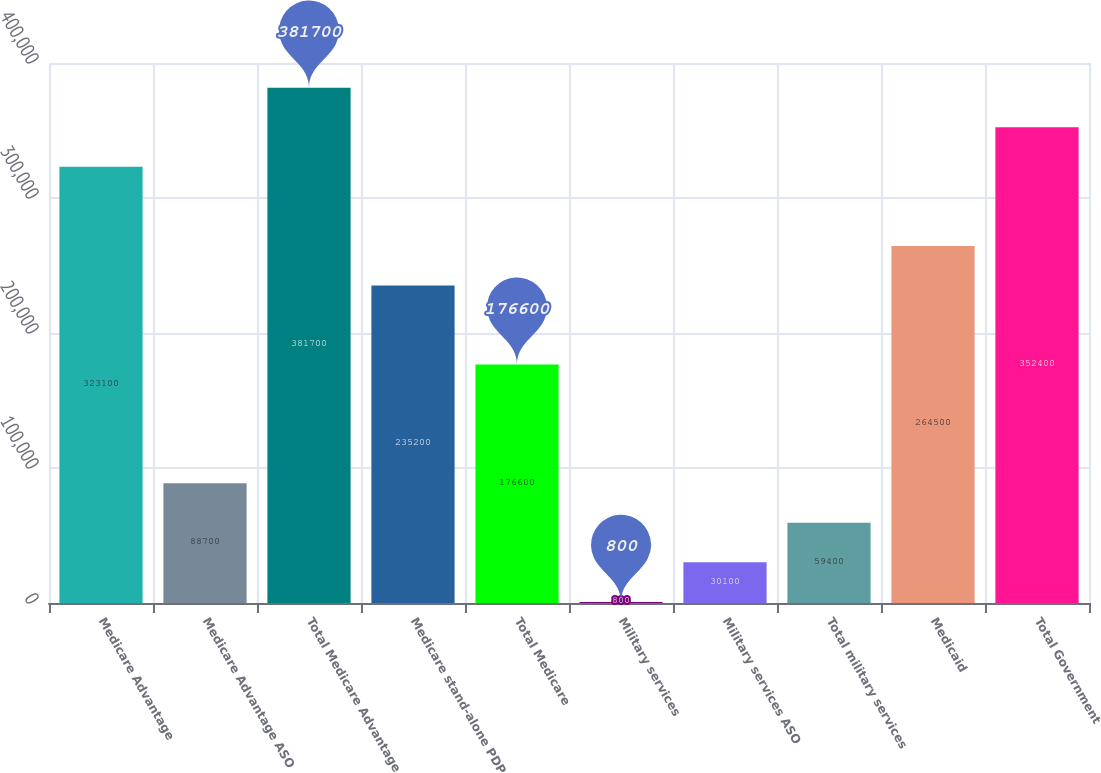<chart> <loc_0><loc_0><loc_500><loc_500><bar_chart><fcel>Medicare Advantage<fcel>Medicare Advantage ASO<fcel>Total Medicare Advantage<fcel>Medicare stand-alone PDP<fcel>Total Medicare<fcel>Military services<fcel>Military services ASO<fcel>Total military services<fcel>Medicaid<fcel>Total Government<nl><fcel>323100<fcel>88700<fcel>381700<fcel>235200<fcel>176600<fcel>800<fcel>30100<fcel>59400<fcel>264500<fcel>352400<nl></chart> 